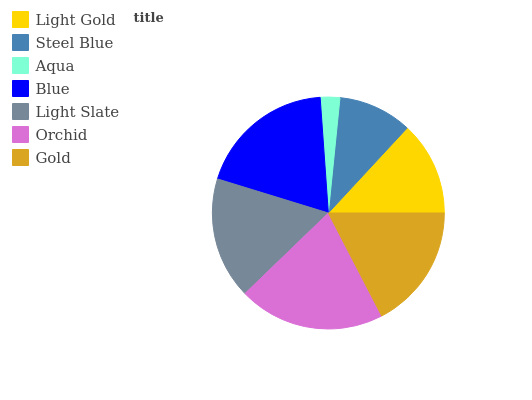Is Aqua the minimum?
Answer yes or no. Yes. Is Orchid the maximum?
Answer yes or no. Yes. Is Steel Blue the minimum?
Answer yes or no. No. Is Steel Blue the maximum?
Answer yes or no. No. Is Light Gold greater than Steel Blue?
Answer yes or no. Yes. Is Steel Blue less than Light Gold?
Answer yes or no. Yes. Is Steel Blue greater than Light Gold?
Answer yes or no. No. Is Light Gold less than Steel Blue?
Answer yes or no. No. Is Light Slate the high median?
Answer yes or no. Yes. Is Light Slate the low median?
Answer yes or no. Yes. Is Light Gold the high median?
Answer yes or no. No. Is Blue the low median?
Answer yes or no. No. 